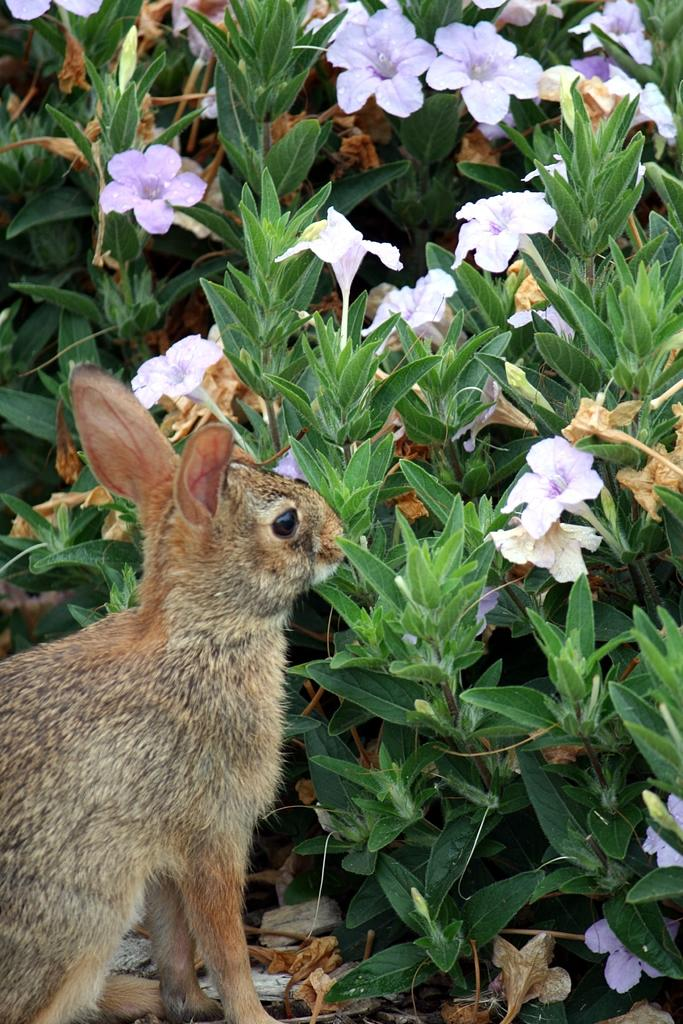What type of living organism is present in the image? There is an animal in the image. What other elements can be seen in the image besides the animal? There are plants and flowers in the image. What type of soap is being used by the animal in the image? There is no soap present in the image, and the animal is not shown using any soap. 